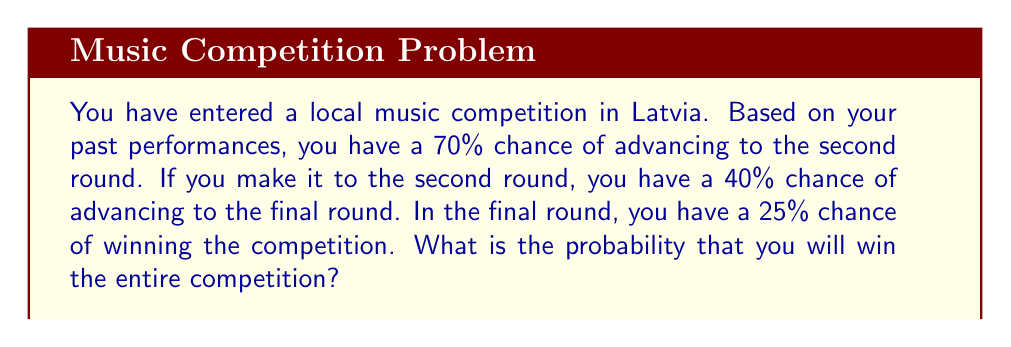Give your solution to this math problem. Let's break this down step-by-step:

1) To win the competition, you need to:
   a) Advance to the second round
   b) Advance from the second round to the final round
   c) Win the final round

2) The probability of each event is:
   a) $P(\text{Advance to second round}) = 0.70$
   b) $P(\text{Advance to final round} | \text{In second round}) = 0.40$
   c) $P(\text{Win final round} | \text{In final round}) = 0.25$

3) To find the probability of all these events occurring, we multiply the individual probabilities:

   $$P(\text{Win competition}) = P(\text{Advance to second round}) \times P(\text{Advance to final round} | \text{In second round}) \times P(\text{Win final round} | \text{In final round})$$

4) Substituting the values:

   $$P(\text{Win competition}) = 0.70 \times 0.40 \times 0.25$$

5) Calculating:

   $$P(\text{Win competition}) = 0.07$$

Therefore, the probability of winning the entire competition is 0.07 or 7%.
Answer: 0.07 